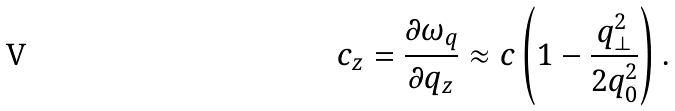<formula> <loc_0><loc_0><loc_500><loc_500>c _ { z } = \frac { \partial \omega _ { q } } { \partial q _ { z } } \approx c \left ( 1 - \frac { q _ { \bot } ^ { 2 } } { 2 q _ { 0 } ^ { 2 } } \right ) .</formula> 